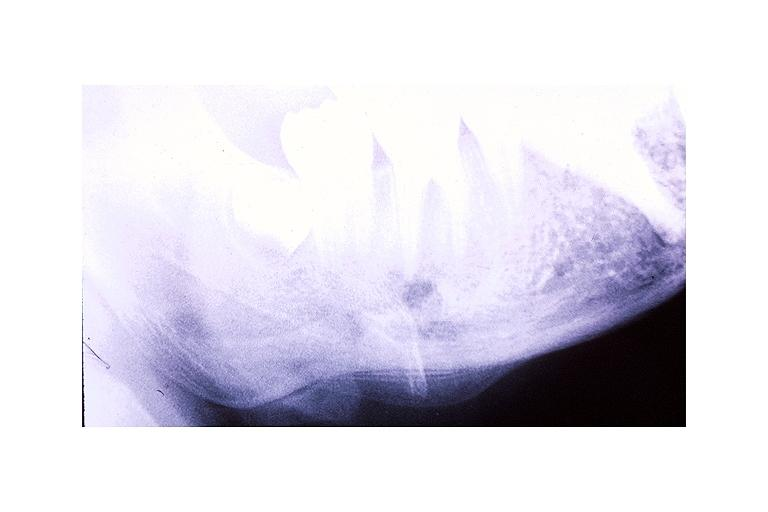where is this?
Answer the question using a single word or phrase. Oral 